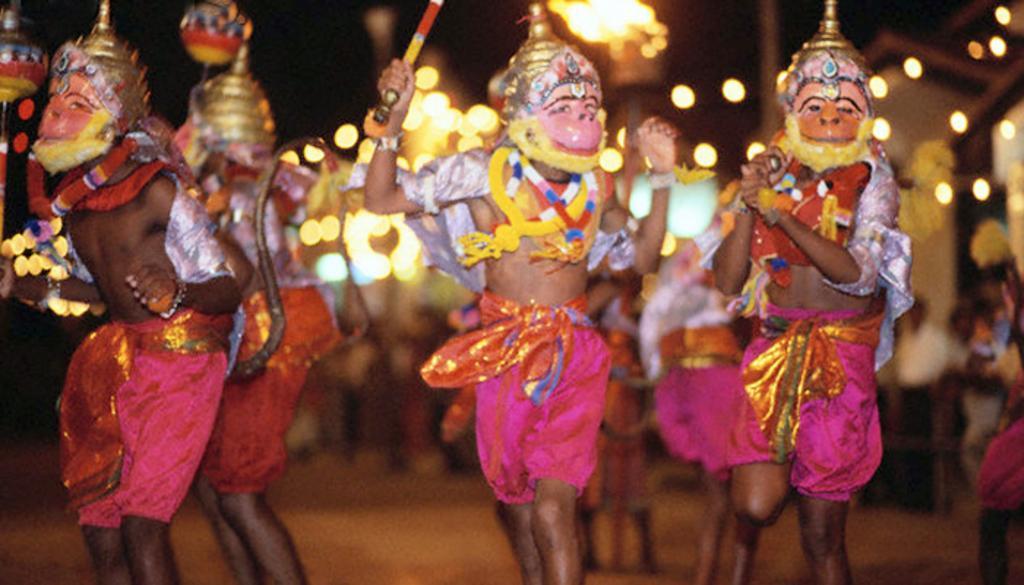Can you describe this image briefly? In the center of the image we can see group of persons performing on the road wearing a masks. In the background we can see persons and lights. 